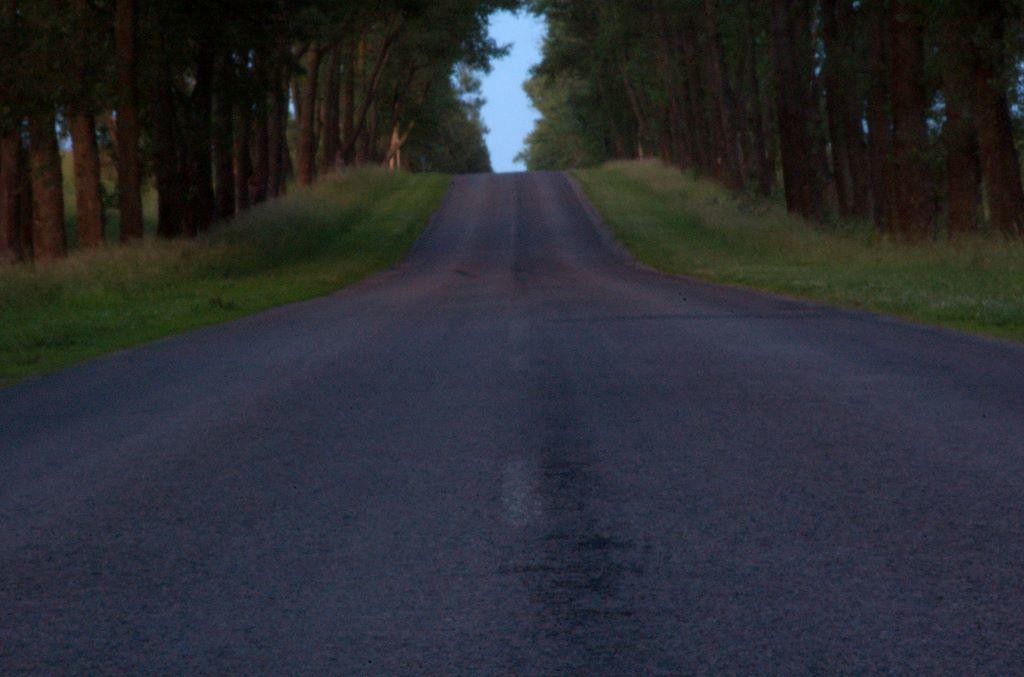What type of pathway can be seen in the image? There is a road in the image. What type of vegetation is present in the image? Shrubs and trees are present in the image. What type of ground cover is visible in the image? Grass is visible in the image. What is visible in the background of the image? The sky is visible in the image. How much wealth is represented by the square in the image? There is no square or representation of wealth present in the image. 